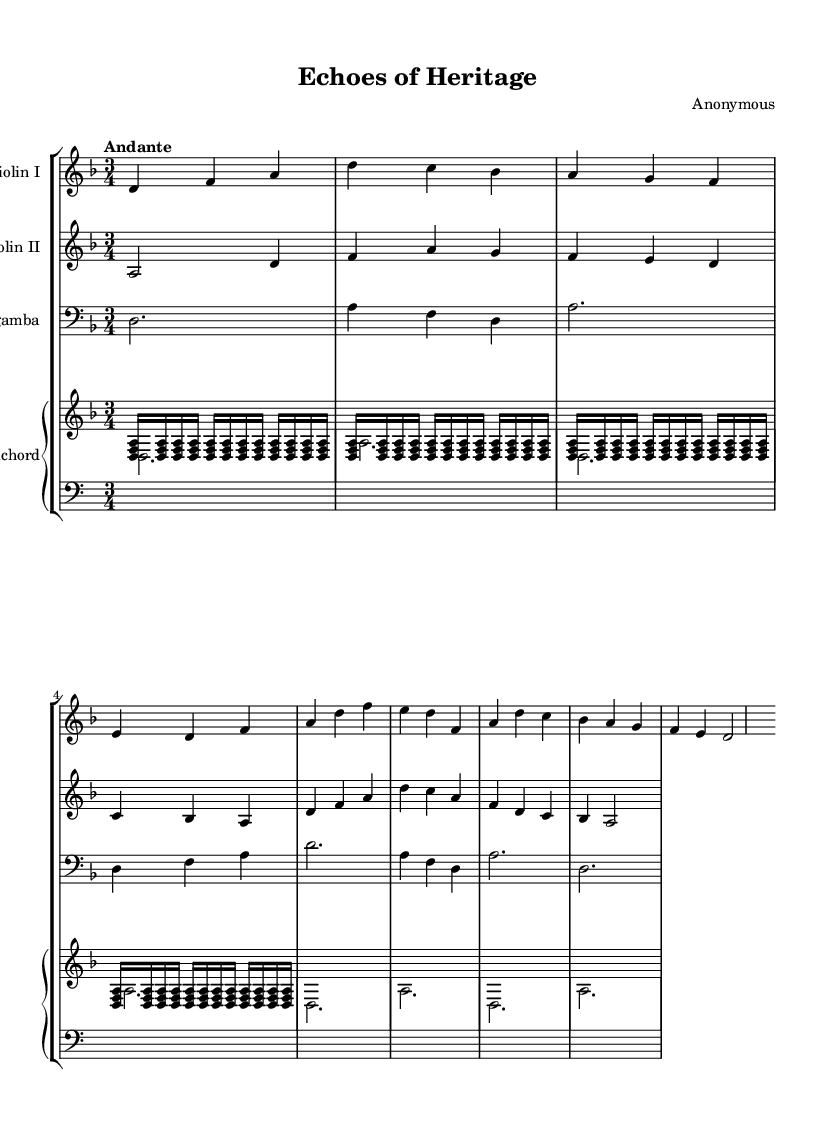What is the key signature of this music? The key signature is D minor, which has one flat (B flat). This can be identified by looking at the key signature section at the beginning of the score.
Answer: D minor What is the time signature of the piece? The time signature is 3/4, indicated at the start of the music, showing that there are three beats in each measure and the quarter note gets one beat.
Answer: 3/4 What is the tempo marking of this piece? The tempo marking is "Andante," which indicates a moderate walking pace. This marking is usually placed above the musical staff, near the beginning of the score.
Answer: Andante How many staves are in the score? There are four staves in the score, as shown in the staff groupings for the two violins, viola da gamba, and harpsichord. Each instrument has its own staff for clarity.
Answer: Four What is the instrumentation of this chamber music? The instrumentation consists of two violins, a viola da gamba, and a harpsichord. This can be determined by the titles labeled above each staff in the score.
Answer: Two violins, viola da gamba, harpsichord How many measures does the first violin part contain? The first violin part contains eight measures. This is counted by identifying the vertical lines (bar lines) that separate each measure in the music.
Answer: Eight What form does the piece appear to take based on the musical structure? The piece appears to take a ternary form (ABA), as evidenced by the recurring themes and changes in the musical material between sections. This can be discerned from the repetition of similar musical phrases.
Answer: Ternary form 